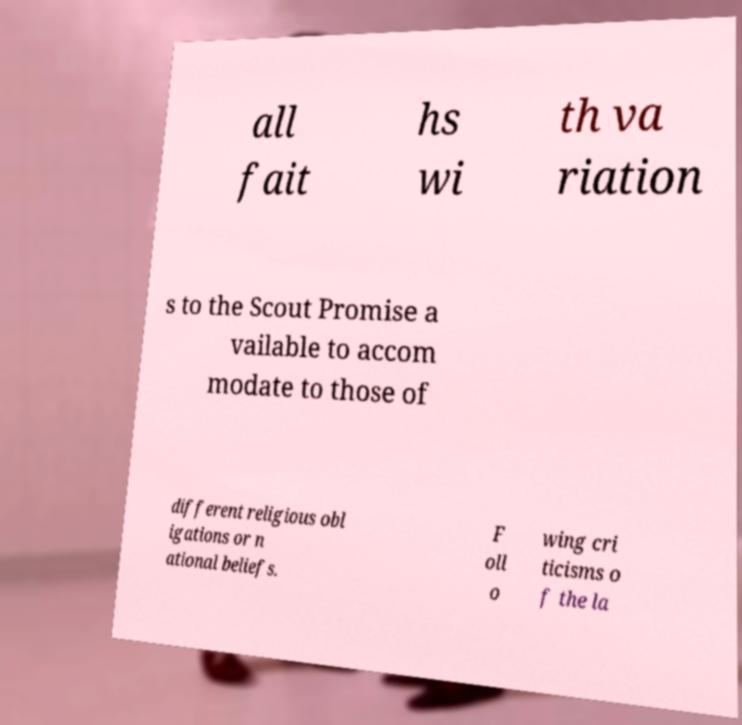I need the written content from this picture converted into text. Can you do that? all fait hs wi th va riation s to the Scout Promise a vailable to accom modate to those of different religious obl igations or n ational beliefs. F oll o wing cri ticisms o f the la 